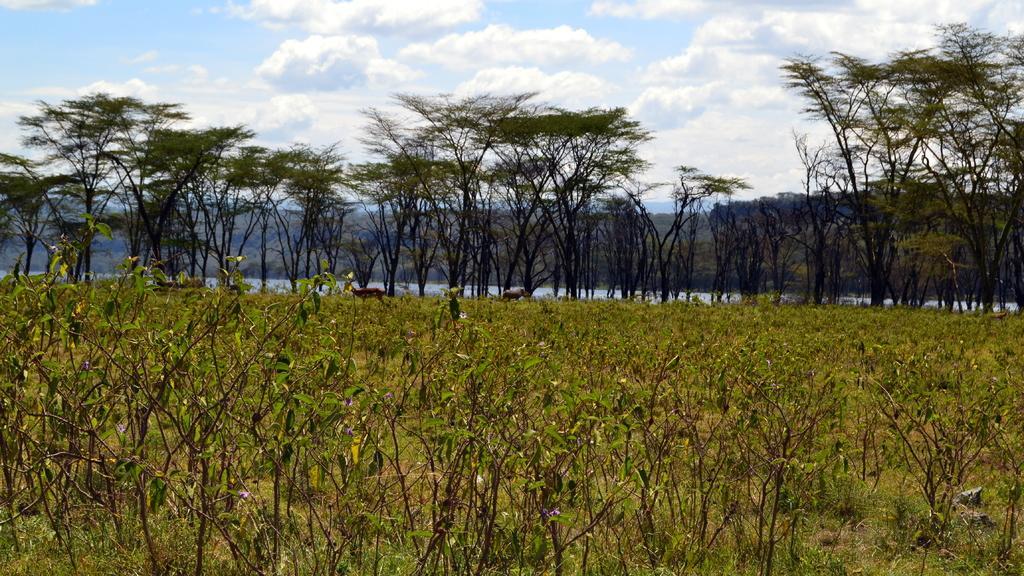Please provide a concise description of this image. There are plants having green color leaves, animals and grass on the ground. In the background, there are trees, there is water, there are mountains and there are clouds in the sky. 